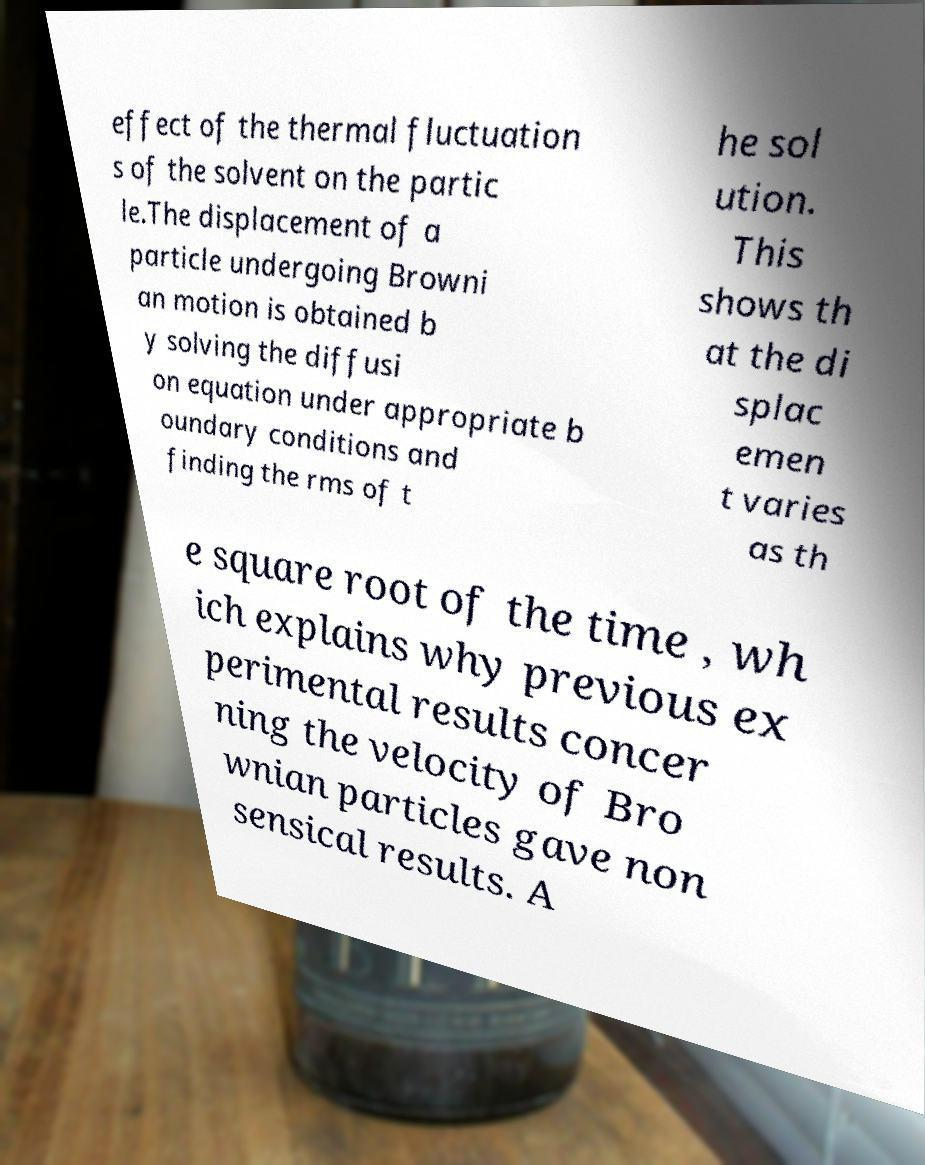Could you assist in decoding the text presented in this image and type it out clearly? effect of the thermal fluctuation s of the solvent on the partic le.The displacement of a particle undergoing Browni an motion is obtained b y solving the diffusi on equation under appropriate b oundary conditions and finding the rms of t he sol ution. This shows th at the di splac emen t varies as th e square root of the time , wh ich explains why previous ex perimental results concer ning the velocity of Bro wnian particles gave non sensical results. A 